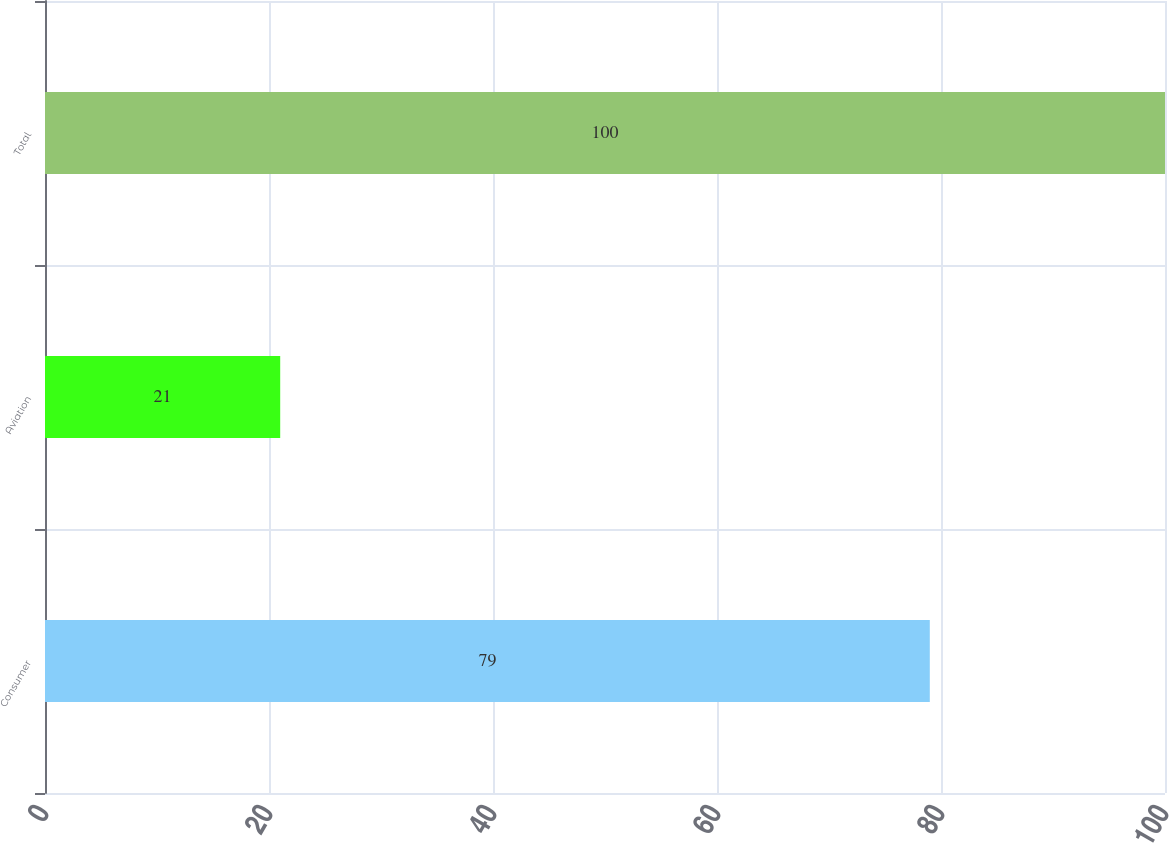Convert chart. <chart><loc_0><loc_0><loc_500><loc_500><bar_chart><fcel>Consumer<fcel>Aviation<fcel>Total<nl><fcel>79<fcel>21<fcel>100<nl></chart> 